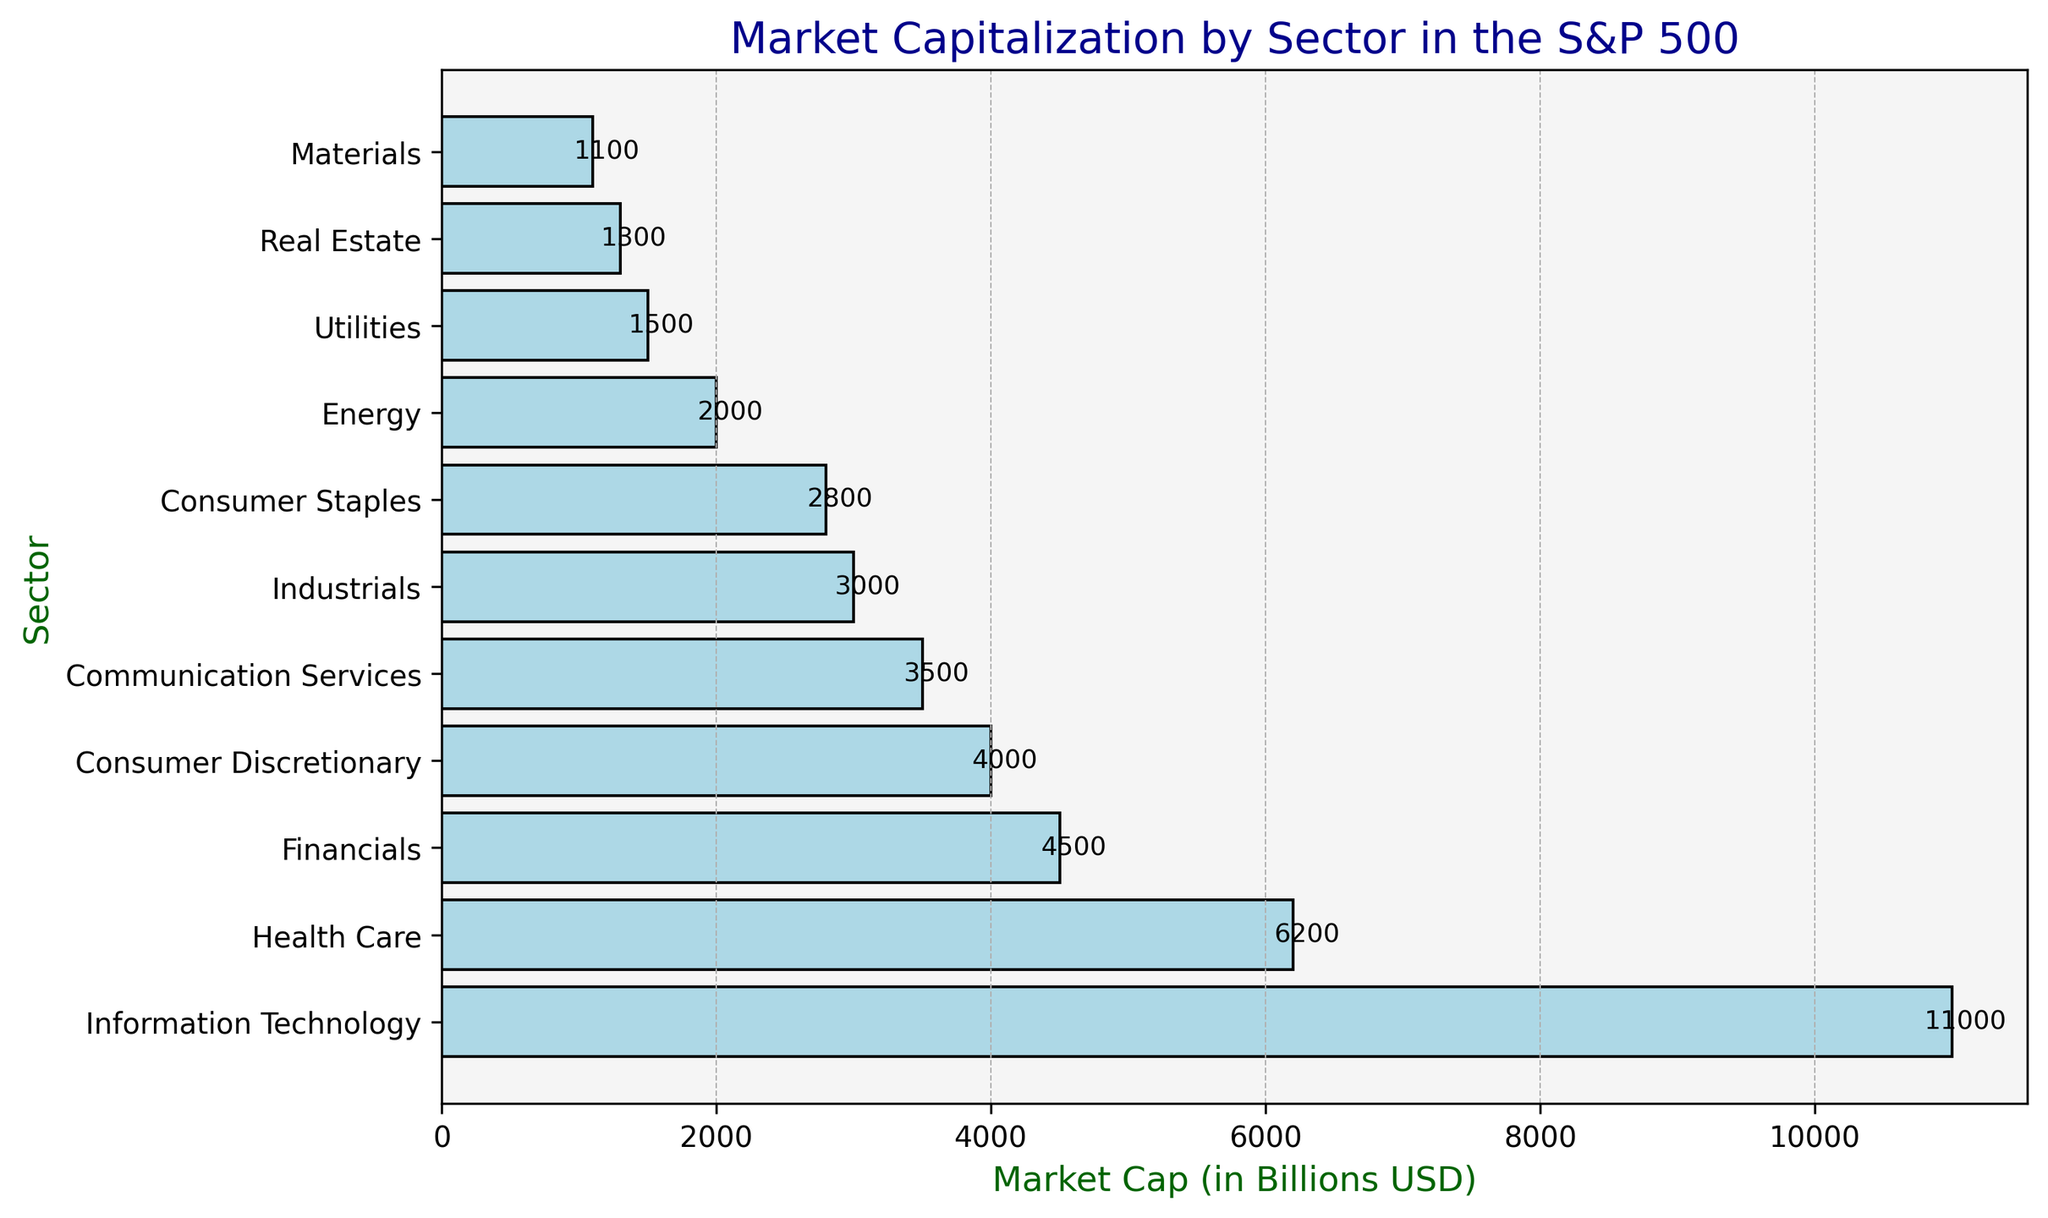Which sector has the highest market capitalization? Look at the bar length and identify the sector with the longest bar, which corresponds to the highest market cap. The "Information Technology" sector has the longest bar at 11000 billion USD.
Answer: Information Technology Which sector has the lowest market capitalization? Look at the bar length and identify the sector with the shortest bar, indicating the lowest market cap. The "Materials" sector has the shortest bar at 1100 billion USD.
Answer: Materials How much more is the market capitalization of Health Care compared to Financials? Subtract the market cap of Financials from Health Care. Health Care: 6200 billion USD, Financials: 4500 billion USD. 6200 - 4500 = 1700.
Answer: 1700 billion USD What is the average market capitalization of Consumer Discretionary and Communication Services sectors? Sum the market caps of both sectors and divide by 2. Consumer Discretionary: 4000, Communication Services: 3500. (4000 + 3500) / 2 = 3750.
Answer: 3750 billion USD Which two sectors combined have a market capitalization closest to the Financials sector? Add market caps of different sector pairs and find the pair whose sum is closest to the Financials market cap (4500 billion USD). Using pairs: Consumer Discretionary (4000) + Utilities (1500) = 5500 (too high), Energy (2000) + Consumer Staples (2800) = 4800 (close but slightly higher), Industrials (3000) + Consumer Staples (2800) = 5800 (too high), Communication Services (3500) + Consumer Staples (2800) = 6300 (too high). Therefore, Consumer Discretionary (4000) + Utilities (1500) = 5500 is the closest pair slightly below Financials, but for closest balance: Energy + Consumer Staples = 4800.
Answer: Energy and Consumer Staples Among the sectors whose market capitalization is below 2000 billion USD, which one has the greatest market capitalization? Identify sectors below 2000 billion USD, then find the largest value among them. Real Estate: 1300, Materials: 1100. Real Estate has the greatest value.
Answer: Real Estate What is the total market capitalization of the three smallest sectors? Sum the market caps of the three sectors with the smallest caps. Materials: 1100, Real Estate: 1300, Utilities: 1500. 1100 + 1300 + 1500 = 3900.
Answer: 3900 billion USD Which sector's market cap is closest to the average market cap across all sectors? Calculate the total market cap and the number of sectors to find the average. Total Market Cap: 11000 + 6200 + 4500 + 4000 + 3500 + 3000 + 2800 + 2000 + 1500 + 1300 + 1100 = 40000. Average Market Cap: 40000 / 11 ≈ 3636. Closest sectors: Communication Services (3500) and Consumer Discretionary (4000). Communication Services is slightly closer.
Answer: Communication Services 